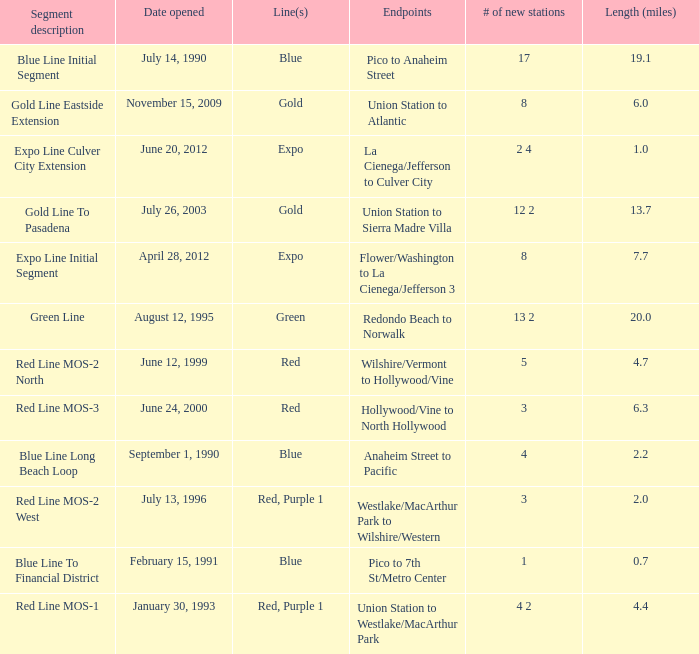What date of segment description red line mos-2 north open? June 12, 1999. 